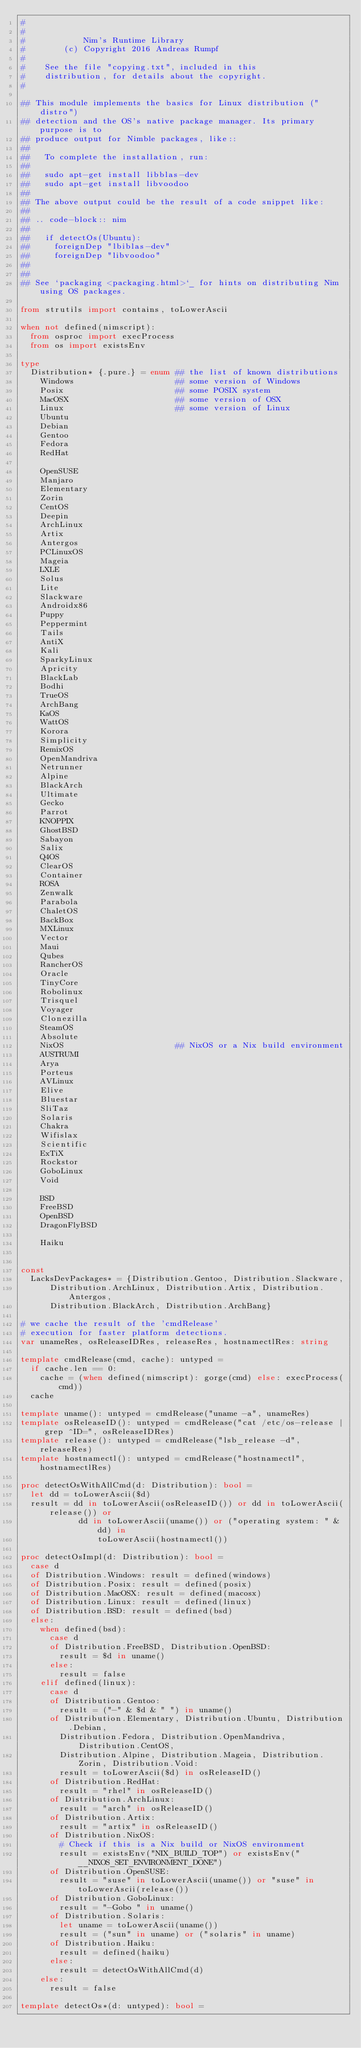<code> <loc_0><loc_0><loc_500><loc_500><_Nim_>#
#
#            Nim's Runtime Library
#        (c) Copyright 2016 Andreas Rumpf
#
#    See the file "copying.txt", included in this
#    distribution, for details about the copyright.
#

## This module implements the basics for Linux distribution ("distro")
## detection and the OS's native package manager. Its primary purpose is to
## produce output for Nimble packages, like::
##
##   To complete the installation, run:
##
##   sudo apt-get install libblas-dev
##   sudo apt-get install libvoodoo
##
## The above output could be the result of a code snippet like:
##
## .. code-block:: nim
##
##   if detectOs(Ubuntu):
##     foreignDep "lbiblas-dev"
##     foreignDep "libvoodoo"
##
##
## See `packaging <packaging.html>`_ for hints on distributing Nim using OS packages.

from strutils import contains, toLowerAscii

when not defined(nimscript):
  from osproc import execProcess
  from os import existsEnv

type
  Distribution* {.pure.} = enum ## the list of known distributions
    Windows                     ## some version of Windows
    Posix                       ## some POSIX system
    MacOSX                      ## some version of OSX
    Linux                       ## some version of Linux
    Ubuntu
    Debian
    Gentoo
    Fedora
    RedHat

    OpenSUSE
    Manjaro
    Elementary
    Zorin
    CentOS
    Deepin
    ArchLinux
    Artix
    Antergos
    PCLinuxOS
    Mageia
    LXLE
    Solus
    Lite
    Slackware
    Androidx86
    Puppy
    Peppermint
    Tails
    AntiX
    Kali
    SparkyLinux
    Apricity
    BlackLab
    Bodhi
    TrueOS
    ArchBang
    KaOS
    WattOS
    Korora
    Simplicity
    RemixOS
    OpenMandriva
    Netrunner
    Alpine
    BlackArch
    Ultimate
    Gecko
    Parrot
    KNOPPIX
    GhostBSD
    Sabayon
    Salix
    Q4OS
    ClearOS
    Container
    ROSA
    Zenwalk
    Parabola
    ChaletOS
    BackBox
    MXLinux
    Vector
    Maui
    Qubes
    RancherOS
    Oracle
    TinyCore
    Robolinux
    Trisquel
    Voyager
    Clonezilla
    SteamOS
    Absolute
    NixOS                       ## NixOS or a Nix build environment
    AUSTRUMI
    Arya
    Porteus
    AVLinux
    Elive
    Bluestar
    SliTaz
    Solaris
    Chakra
    Wifislax
    Scientific
    ExTiX
    Rockstor
    GoboLinux
    Void

    BSD
    FreeBSD
    OpenBSD
    DragonFlyBSD

    Haiku


const
  LacksDevPackages* = {Distribution.Gentoo, Distribution.Slackware,
      Distribution.ArchLinux, Distribution.Artix, Distribution.Antergos,
      Distribution.BlackArch, Distribution.ArchBang}

# we cache the result of the 'cmdRelease'
# execution for faster platform detections.
var unameRes, osReleaseIDRes, releaseRes, hostnamectlRes: string

template cmdRelease(cmd, cache): untyped =
  if cache.len == 0:
    cache = (when defined(nimscript): gorge(cmd) else: execProcess(cmd))
  cache

template uname(): untyped = cmdRelease("uname -a", unameRes)
template osReleaseID(): untyped = cmdRelease("cat /etc/os-release | grep ^ID=", osReleaseIDRes)
template release(): untyped = cmdRelease("lsb_release -d", releaseRes)
template hostnamectl(): untyped = cmdRelease("hostnamectl", hostnamectlRes)

proc detectOsWithAllCmd(d: Distribution): bool =
  let dd = toLowerAscii($d)
  result = dd in toLowerAscii(osReleaseID()) or dd in toLowerAscii(release()) or
            dd in toLowerAscii(uname()) or ("operating system: " & dd) in
                toLowerAscii(hostnamectl())

proc detectOsImpl(d: Distribution): bool =
  case d
  of Distribution.Windows: result = defined(windows)
  of Distribution.Posix: result = defined(posix)
  of Distribution.MacOSX: result = defined(macosx)
  of Distribution.Linux: result = defined(linux)
  of Distribution.BSD: result = defined(bsd)
  else:
    when defined(bsd):
      case d
      of Distribution.FreeBSD, Distribution.OpenBSD:
        result = $d in uname()
      else:
        result = false
    elif defined(linux):
      case d
      of Distribution.Gentoo:
        result = ("-" & $d & " ") in uname()
      of Distribution.Elementary, Distribution.Ubuntu, Distribution.Debian,
        Distribution.Fedora, Distribution.OpenMandriva, Distribution.CentOS,
        Distribution.Alpine, Distribution.Mageia, Distribution.Zorin, Distribution.Void:
        result = toLowerAscii($d) in osReleaseID()
      of Distribution.RedHat:
        result = "rhel" in osReleaseID()
      of Distribution.ArchLinux:
        result = "arch" in osReleaseID()
      of Distribution.Artix:
        result = "artix" in osReleaseID()
      of Distribution.NixOS:
        # Check if this is a Nix build or NixOS environment
        result = existsEnv("NIX_BUILD_TOP") or existsEnv("__NIXOS_SET_ENVIRONMENT_DONE")
      of Distribution.OpenSUSE:
        result = "suse" in toLowerAscii(uname()) or "suse" in toLowerAscii(release())
      of Distribution.GoboLinux:
        result = "-Gobo " in uname()
      of Distribution.Solaris:
        let uname = toLowerAscii(uname())
        result = ("sun" in uname) or ("solaris" in uname)
      of Distribution.Haiku:
        result = defined(haiku)
      else:
        result = detectOsWithAllCmd(d)
    else:
      result = false

template detectOs*(d: untyped): bool =</code> 